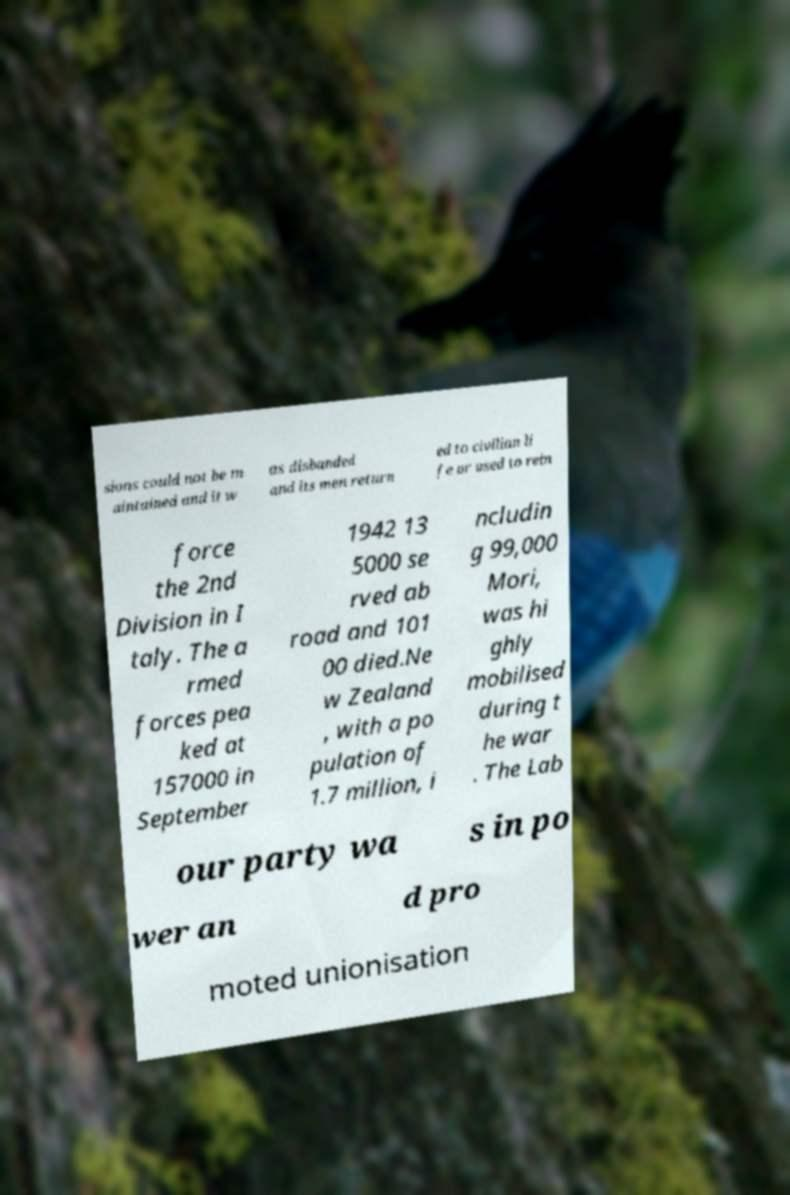Could you extract and type out the text from this image? sions could not be m aintained and it w as disbanded and its men return ed to civilian li fe or used to rein force the 2nd Division in I taly. The a rmed forces pea ked at 157000 in September 1942 13 5000 se rved ab road and 101 00 died.Ne w Zealand , with a po pulation of 1.7 million, i ncludin g 99,000 Mori, was hi ghly mobilised during t he war . The Lab our party wa s in po wer an d pro moted unionisation 